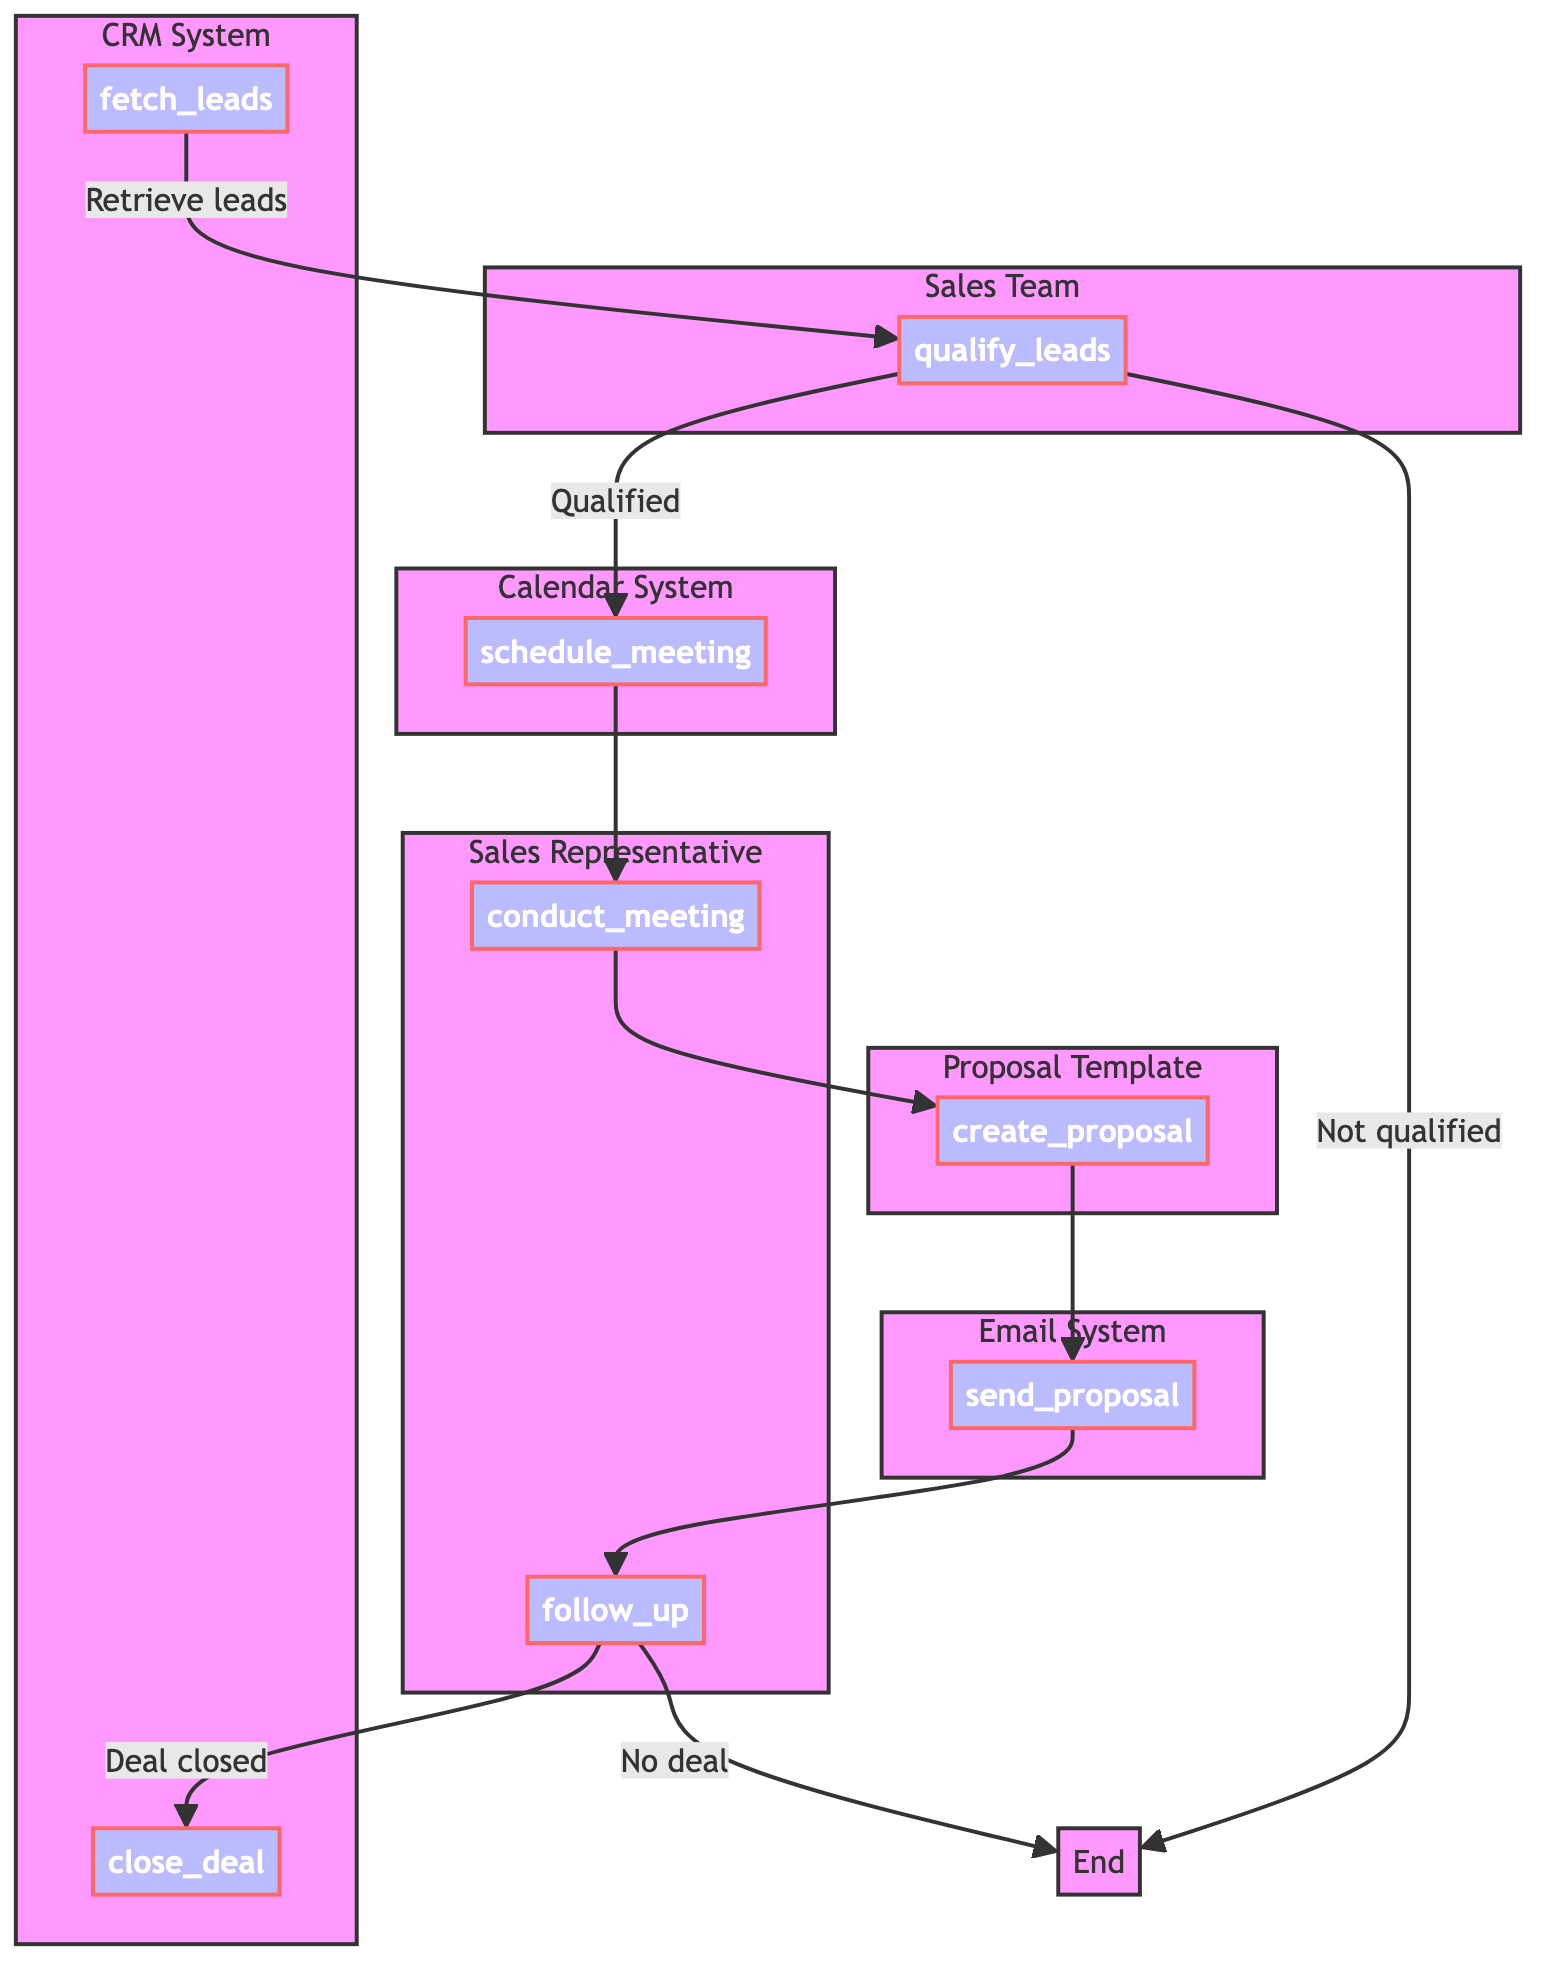What is the first step in the Sales Pipeline Review Process? The first step in the process is "fetch_leads," where new sales leads are retrieved from the CRM system.
Answer: fetch leads How many main steps are there in the Sales Pipeline Review Process? The diagram depicts a total of seven main steps from fetching leads to closing the deal.
Answer: seven What happens if leads are not qualified? If leads are not qualified, the flowchart indicates that the process ends, with no further steps taken.
Answer: End Which entity is responsible for conducting the meeting? The diagram specifies that the "Sales Representative" is responsible for conducting the meeting with the lead.
Answer: Sales Representative What do the qualified leads lead to in the process? Qualified leads lead to scheduling a meeting, where an initial discussion is arranged with them.
Answer: schedule meeting What are the criteria used to qualify leads? The qualification criteria listed in the diagram are Budget, Authority, Need, and Timing, which are essential for assessing leads.
Answer: Budget, Authority, Need, Timing Which step follows sending the proposal? After sending the proposal, the next step is to follow up with the lead to address questions and progress towards closing the sale.
Answer: follow up What is the final step in the Sales Pipeline Review Process? The final step in the process is to close the deal and update the CRM system accordingly.
Answer: close deal What system is used to send the proposal? The proposal is sent using the "Email System," which is responsible for communicating the sales proposal to the lead.
Answer: Email System 